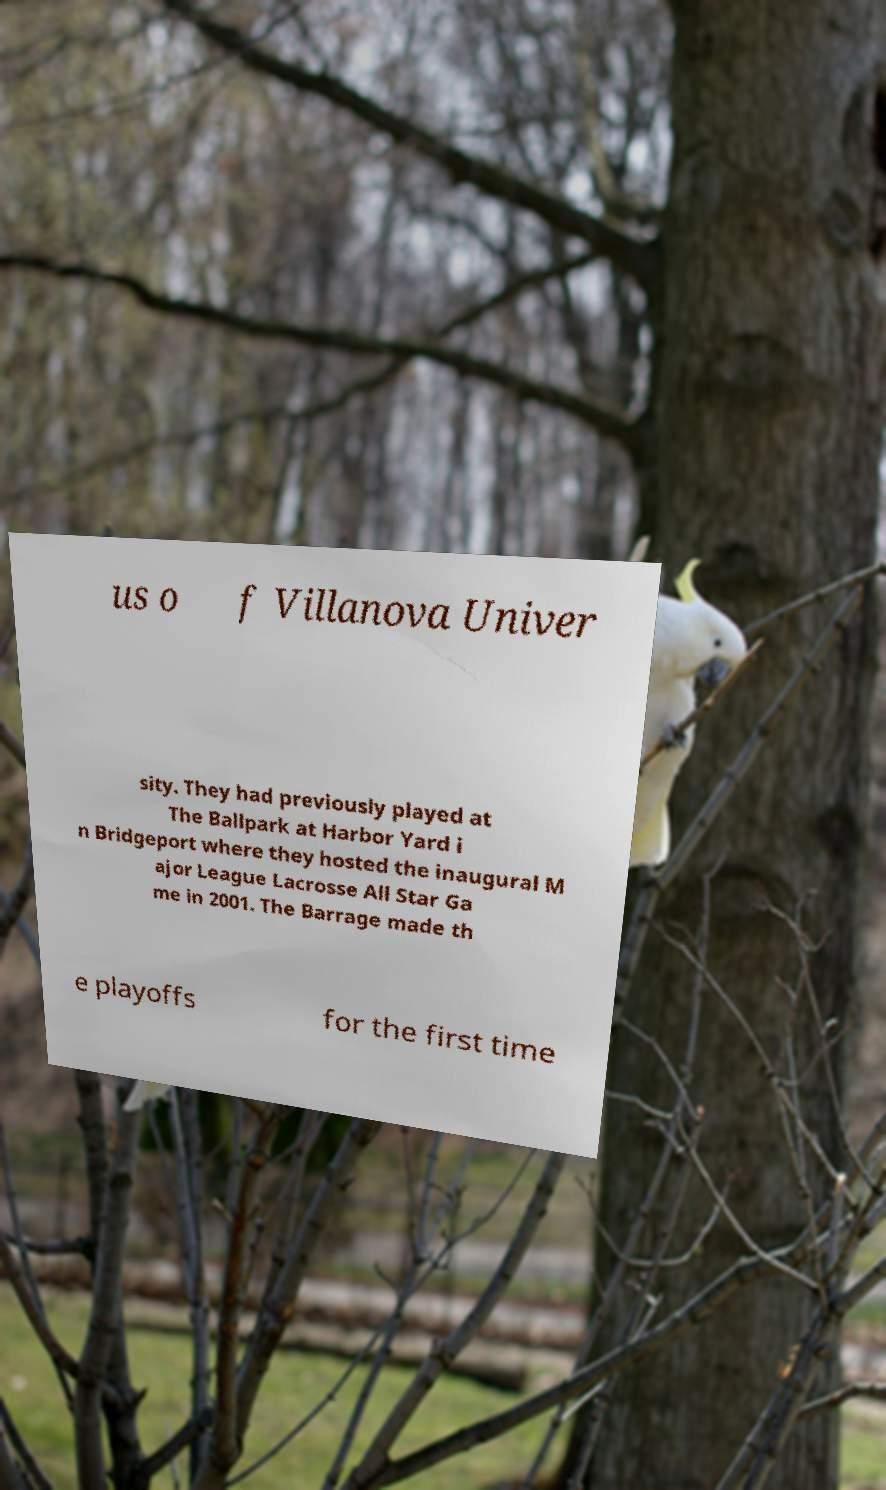I need the written content from this picture converted into text. Can you do that? us o f Villanova Univer sity. They had previously played at The Ballpark at Harbor Yard i n Bridgeport where they hosted the inaugural M ajor League Lacrosse All Star Ga me in 2001. The Barrage made th e playoffs for the first time 